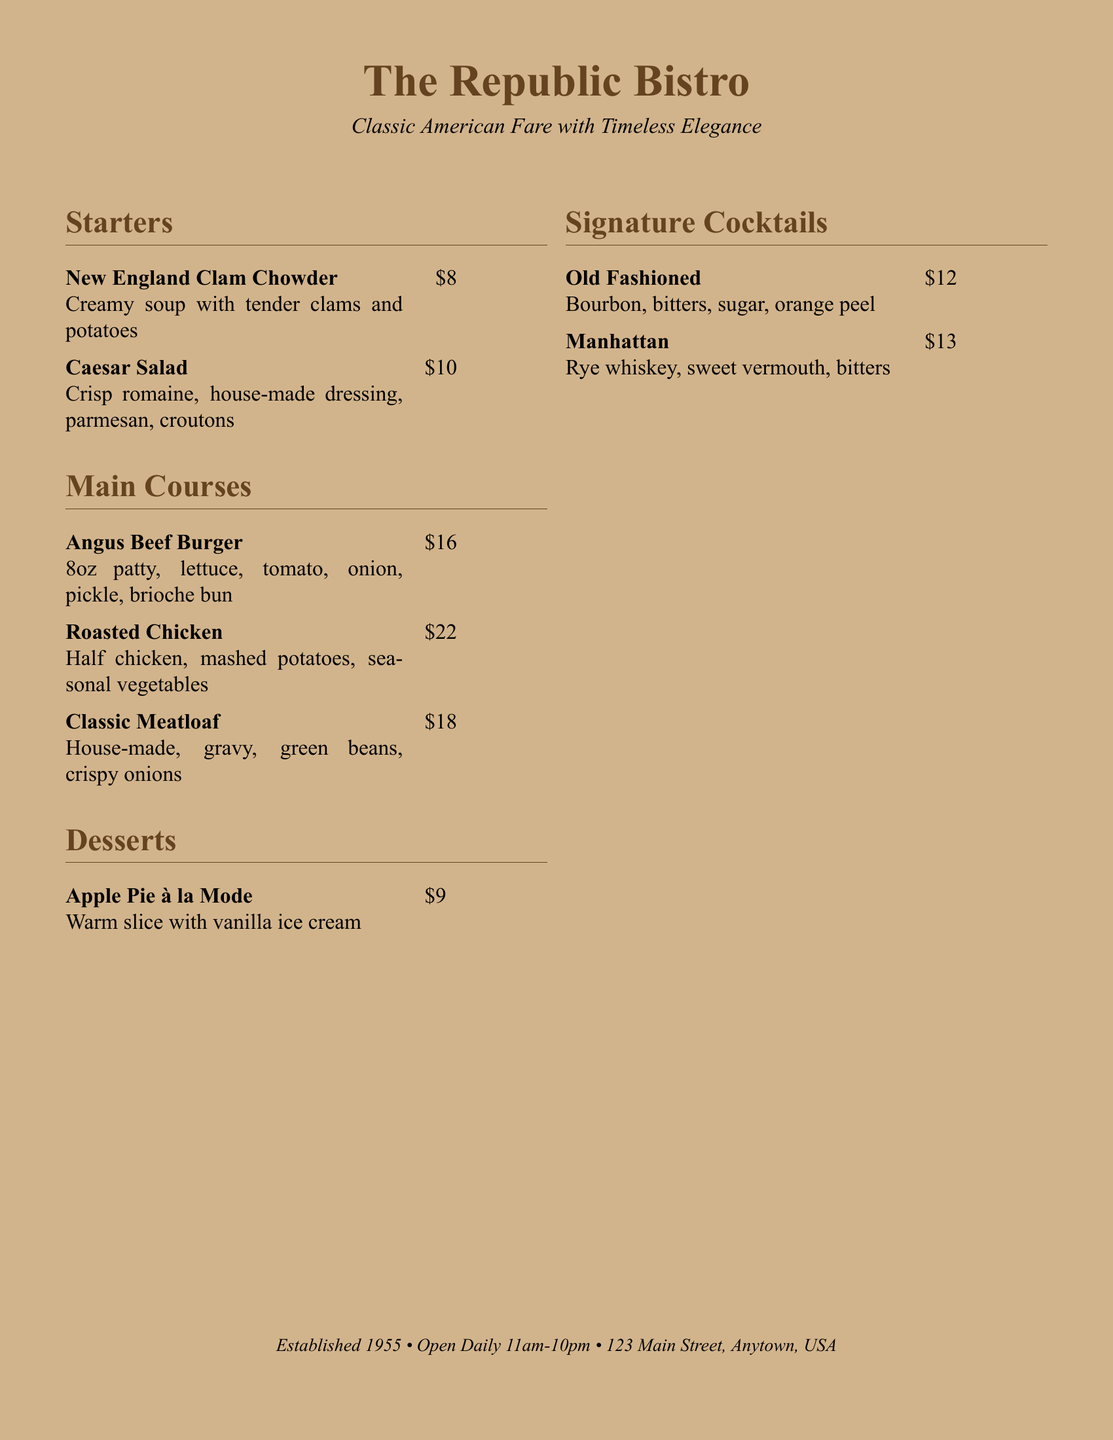What is the name of the restaurant? The restaurant is titled prominently at the top of the menu.
Answer: The Republic Bistro What year was the restaurant established? This information is provided in small print at the bottom of the document.
Answer: 1955 How much does the New England Clam Chowder cost? The price is listed next to the item in the Starters section of the menu.
Answer: $8 What is included in the Angus Beef Burger? The description following the burger name lists all components included.
Answer: 8oz patty, lettuce, tomato, onion, pickle, brioche bun Which cocktail contains rye whiskey? This requires referencing the Signature Cocktails section to find the relevant drink.
Answer: Manhattan How many main course options are listed on the menu? The main courses section contains a specific number of items, which can be counted.
Answer: 3 What dessert is served warm with vanilla ice cream? The dessert section details the specific dessert that matches this description.
Answer: Apple Pie à la Mode What color is the background of the menu? The visual layout of the document describes its background color.
Answer: Light brown What time does the restaurant open daily? The opening time is specified in the establishment details at the bottom.
Answer: 11am 